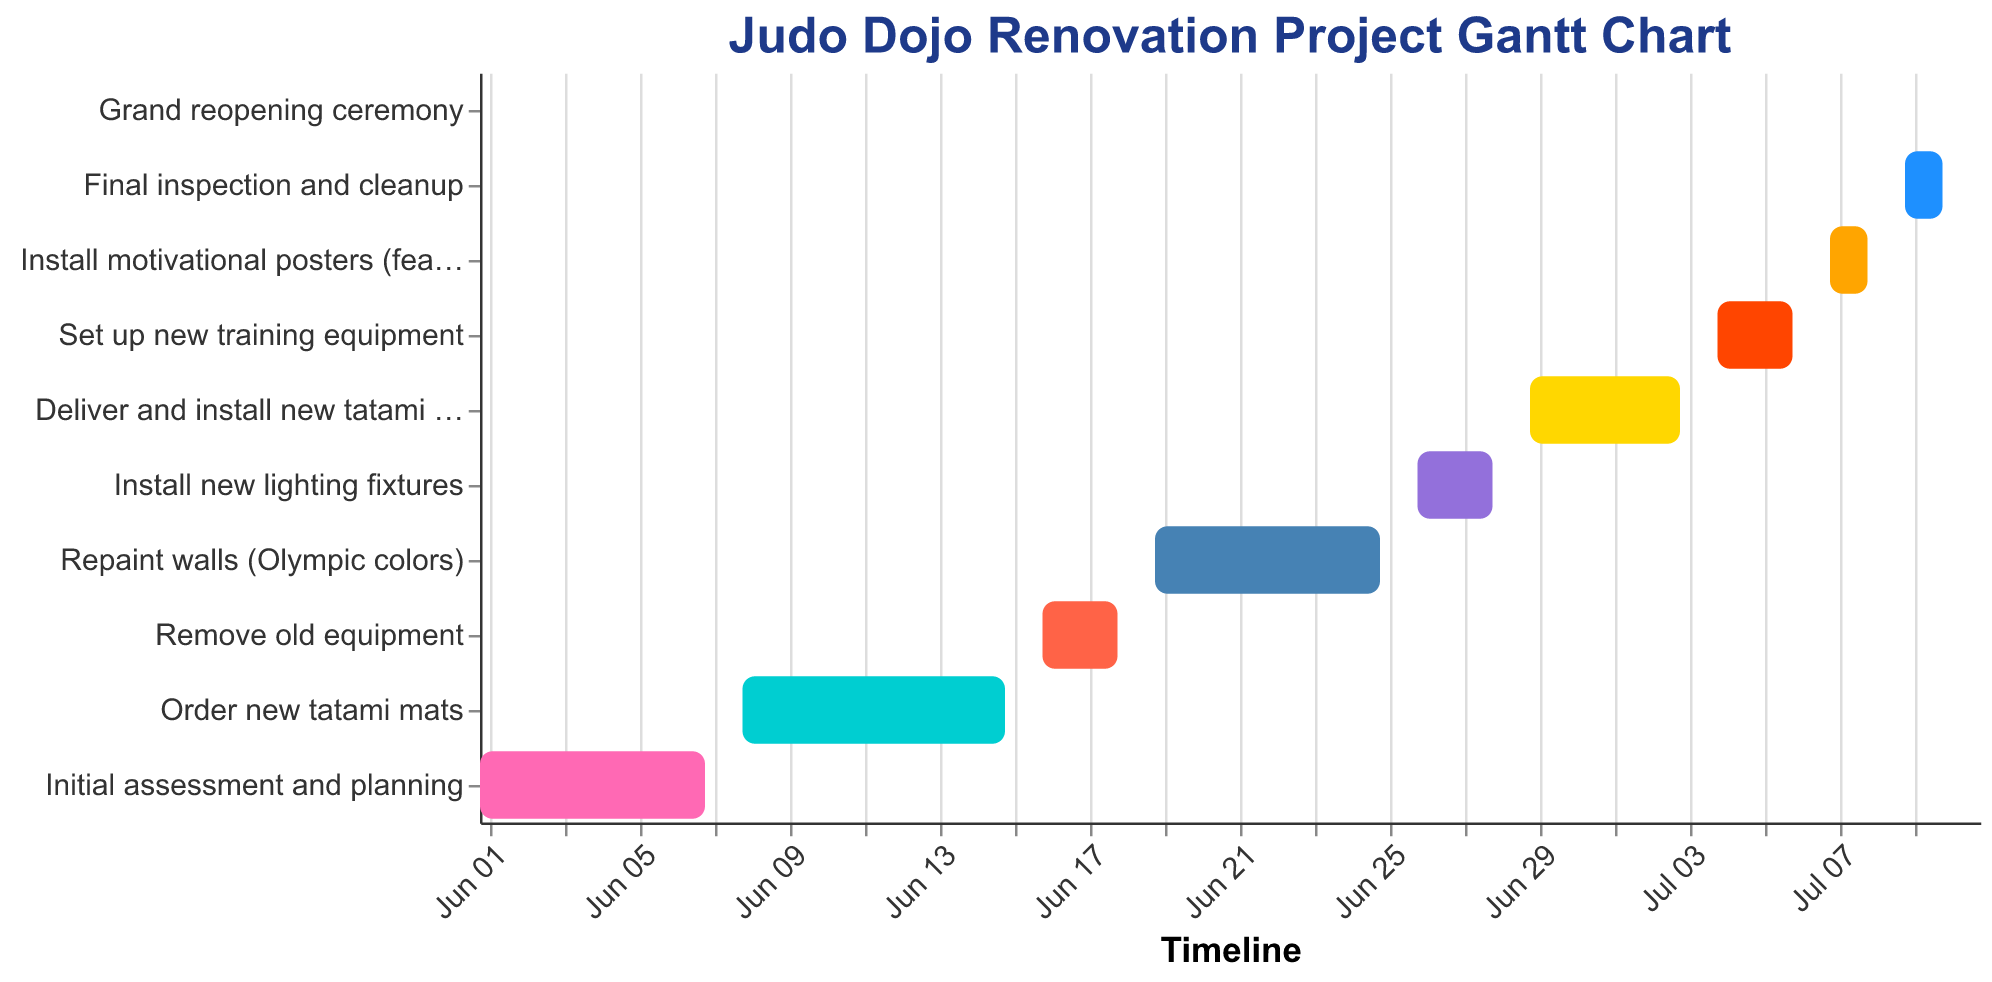What is the title of the chart? Look at the top of the figure where the title is typically located. The title is a short description of what the chart is about.
Answer: Judo Dojo Renovation Project Gantt Chart What task starts immediately after the "Initial assessment and planning"? Identify the task that has its start date immediately following the end date of the "Initial assessment and planning" task.
Answer: Order new tatami mats Which task has the shortest duration? Look for the task with the smallest value in the "Duration" column.
Answer: Grand reopening ceremony How many days does the "Repaint walls (Olympic colors)" task take to complete? Refer to the "Duration" value for the "Repaint walls (Olympic colors)" task.
Answer: 7 days Which tasks have the same duration and what is that duration? Identify tasks with identical "Duration" values and specify what that duration is. Tasks with the same duration can be compared directly in the figure.
Answer: Remove old equipment, Install new lighting fixtures, and Set up new training equipment all take 3 days What is the total time span from the start of the "Initial assessment and planning" to the end of the "Final inspection and cleanup"? Calculate the number of days between the start date of the first task "Initial assessment and planning" and the end date of the last task before the grand reopening, "Final inspection and cleanup".
Answer: 2023-06-01 to 2023-07-10 Compare the durations of "Order new tatami mats" and "Deliver and install new tatami mats". Which one takes longer and by how many days? Look at the "Duration" values of both tasks and subtract the shorter duration from the longer one to find the difference.
Answer: Order new tatami mats takes longer by 3 days Which task involves hanging motivational posters featuring 2008 Olympians? Identify the task from its description which clearly mentions the action involving motivational posters.
Answer: Install motivational posters (featuring 2008 Olympians) What is the final task before the grand reopening ceremony? Identify the last task listed before the "Grand reopening ceremony" in the order of the timeline.
Answer: Final inspection and cleanup 